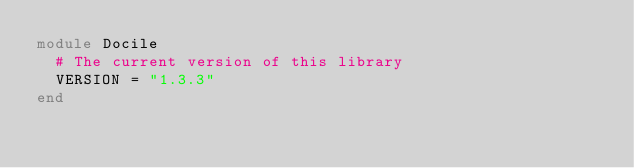<code> <loc_0><loc_0><loc_500><loc_500><_Ruby_>module Docile
  # The current version of this library
  VERSION = "1.3.3"
end
</code> 